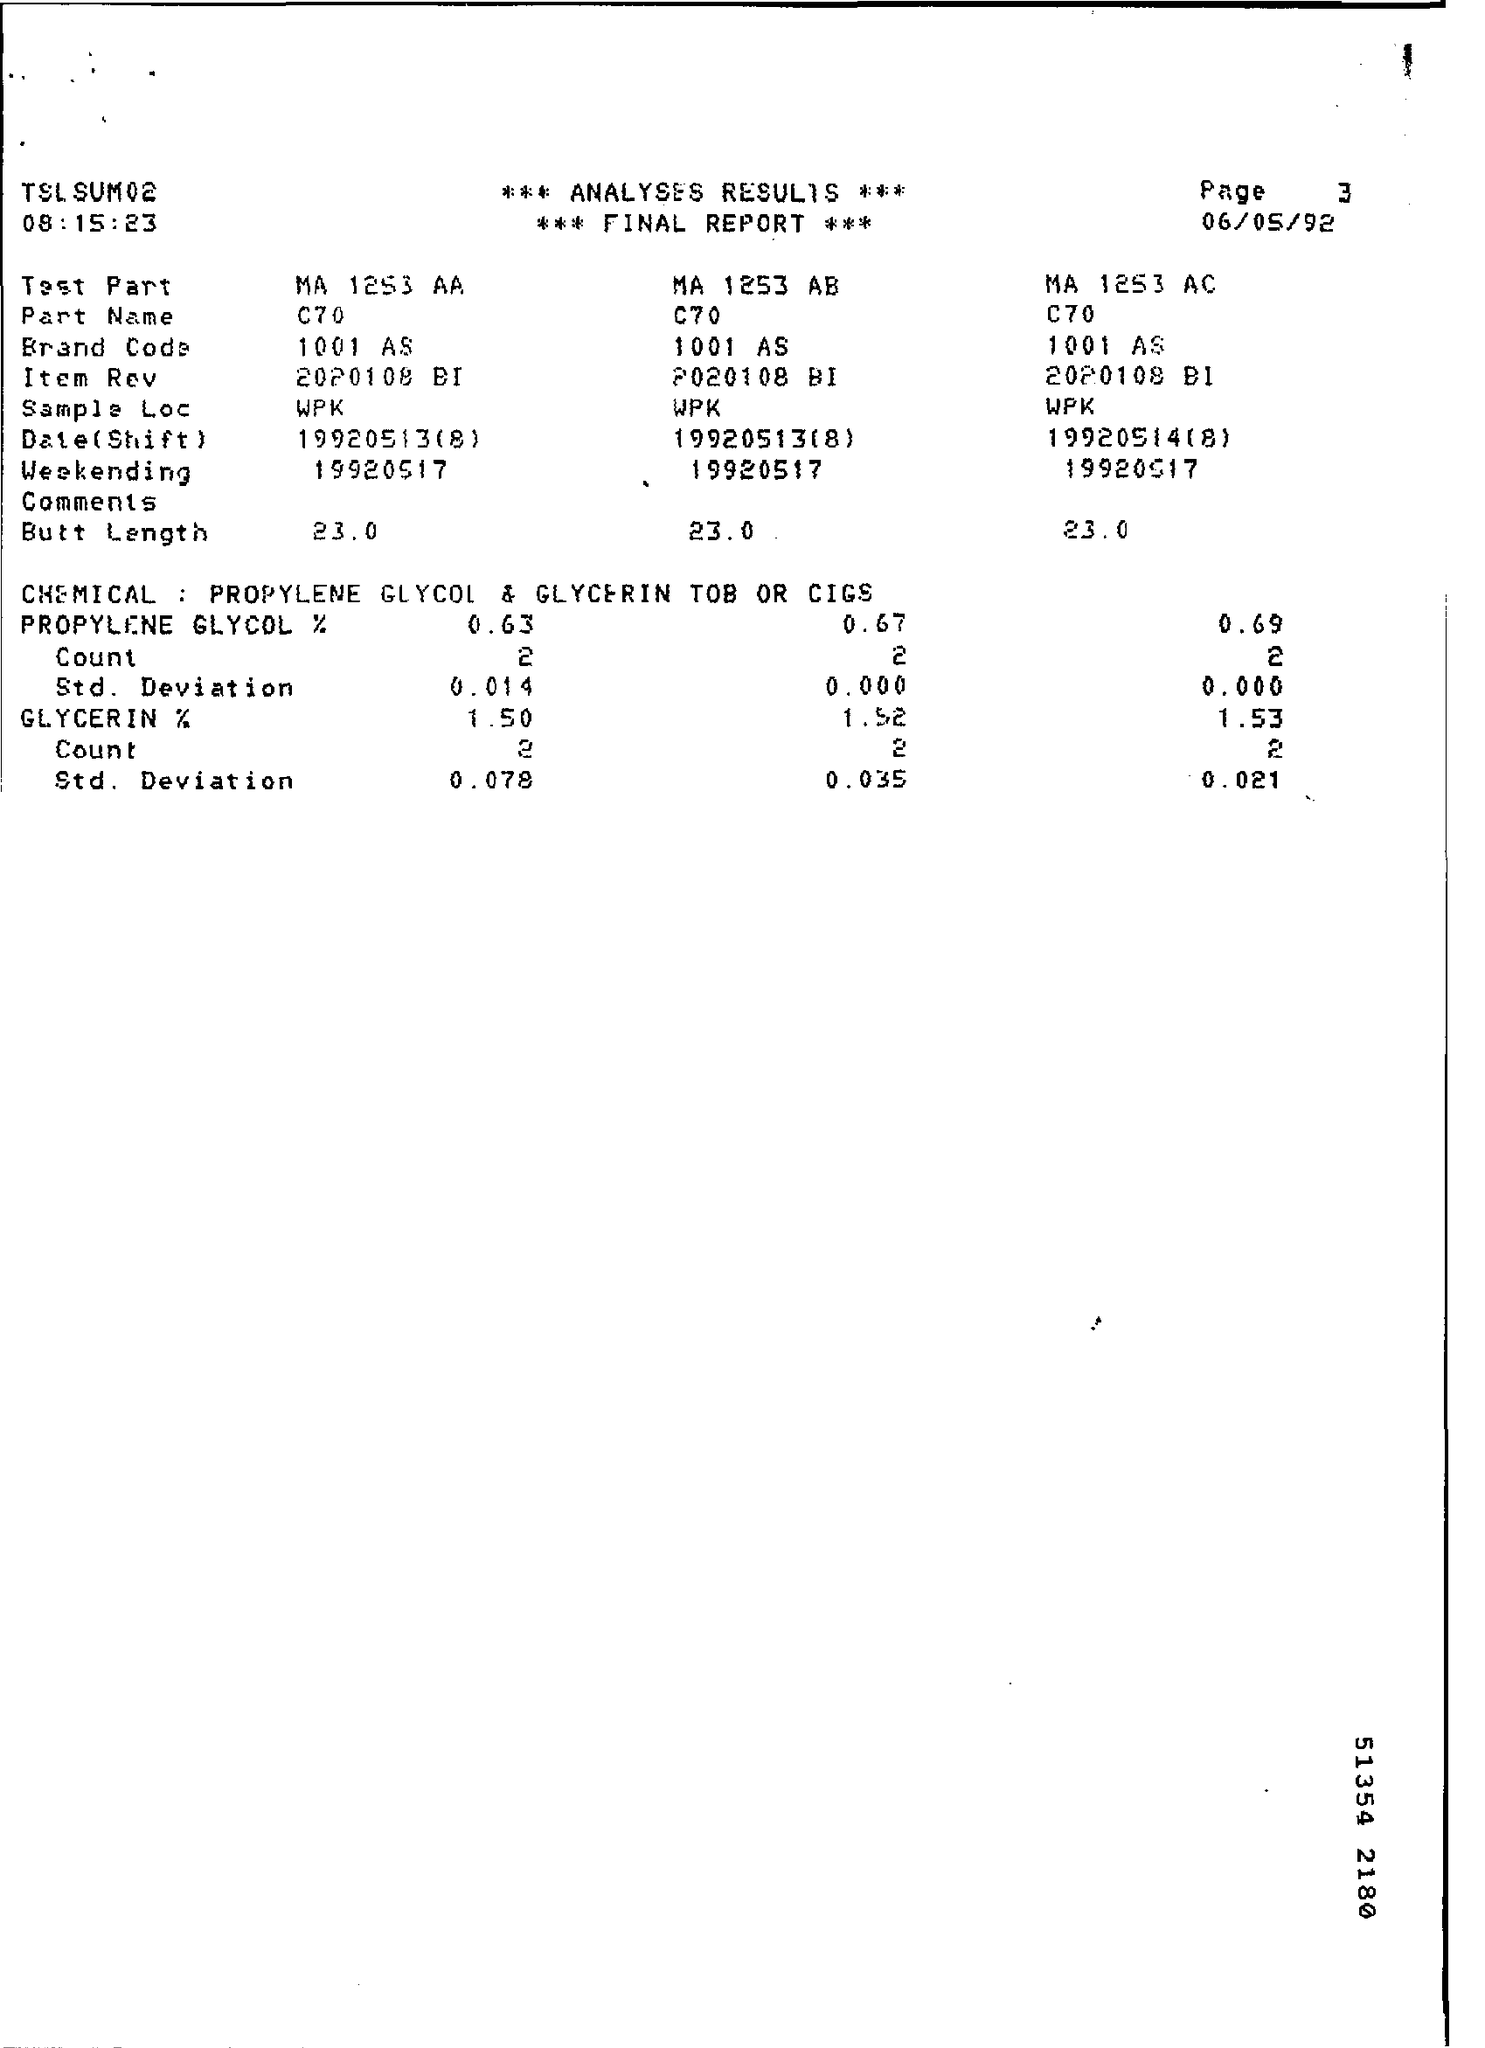What is the Page Number ?
Your answer should be very brief. Page 3. When is the Memorandum dated on ?
Keep it short and to the point. 06/05/92. What is the Part Name ?
Provide a short and direct response. C70. What is the Sample Loc ?
Provide a succinct answer. Wpk. 